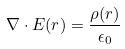Convert formula to latex. <formula><loc_0><loc_0><loc_500><loc_500>\nabla \cdot E ( r ) = \frac { \rho ( r ) } { \epsilon _ { 0 } }</formula> 